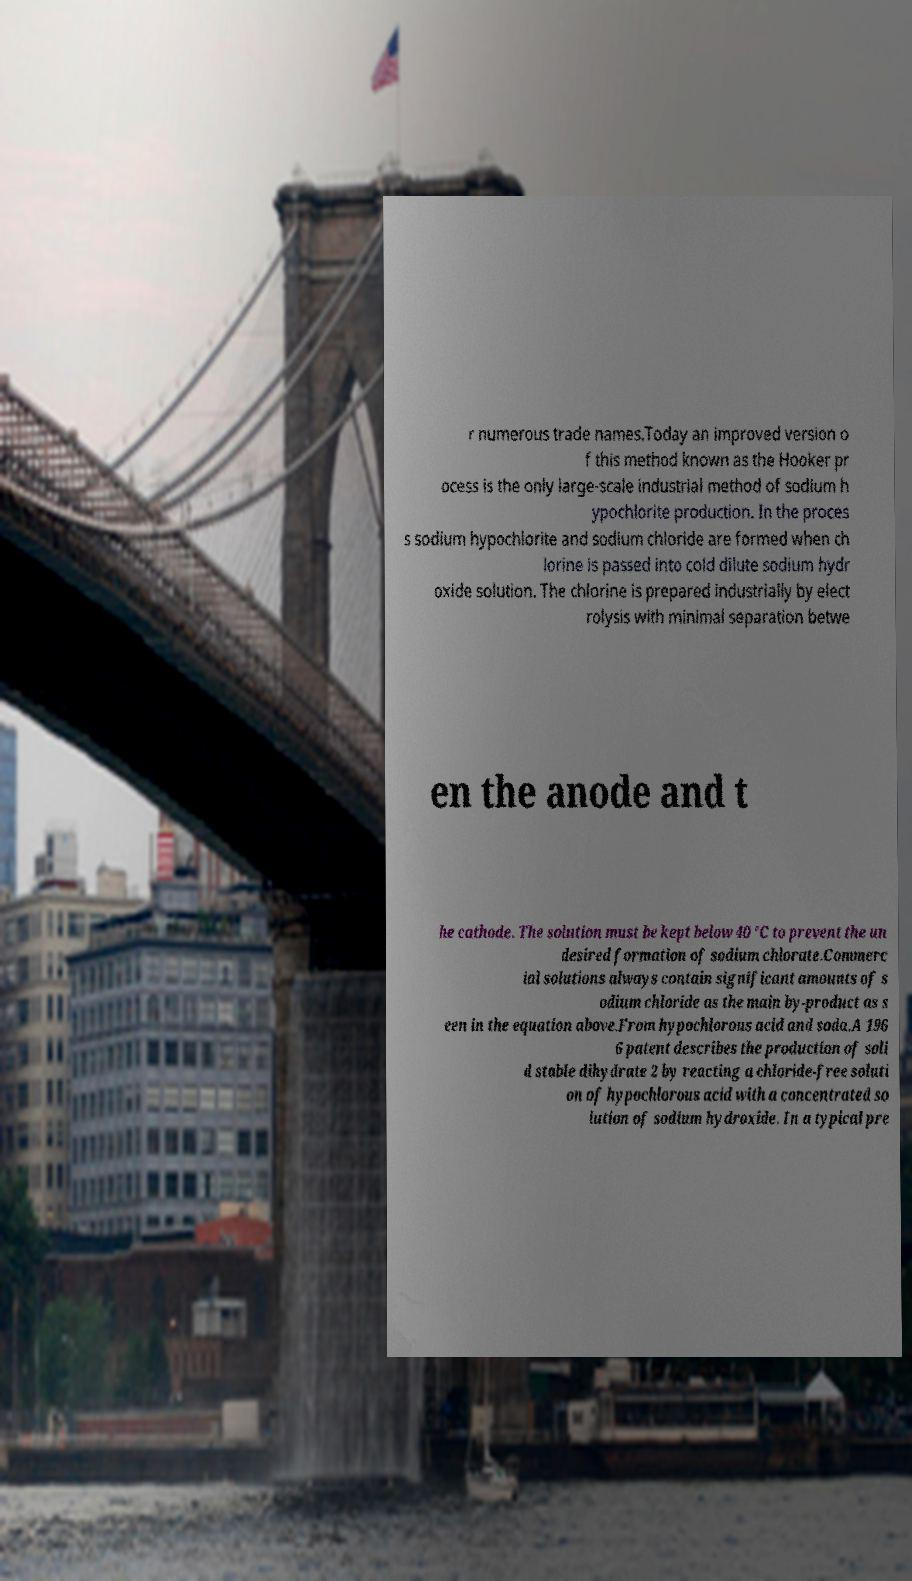For documentation purposes, I need the text within this image transcribed. Could you provide that? r numerous trade names.Today an improved version o f this method known as the Hooker pr ocess is the only large-scale industrial method of sodium h ypochlorite production. In the proces s sodium hypochlorite and sodium chloride are formed when ch lorine is passed into cold dilute sodium hydr oxide solution. The chlorine is prepared industrially by elect rolysis with minimal separation betwe en the anode and t he cathode. The solution must be kept below 40 °C to prevent the un desired formation of sodium chlorate.Commerc ial solutions always contain significant amounts of s odium chloride as the main by-product as s een in the equation above.From hypochlorous acid and soda.A 196 6 patent describes the production of soli d stable dihydrate 2 by reacting a chloride-free soluti on of hypochlorous acid with a concentrated so lution of sodium hydroxide. In a typical pre 